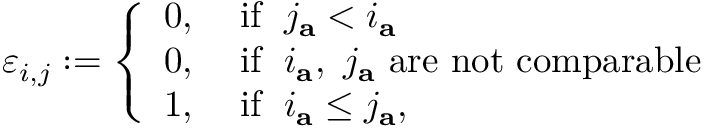<formula> <loc_0><loc_0><loc_500><loc_500>\varepsilon _ { i , j } \colon = \left \{ \begin{array} { l l } { 0 , } & { \, i f \, j _ { a } < i _ { a } } \\ { 0 , } & { \, i f \, i _ { a } , \ j _ { a } a r e n o t c o m p a r a b l e } \\ { 1 , } & { \, i f \, i _ { a } \leq j _ { a } , } \end{array}</formula> 